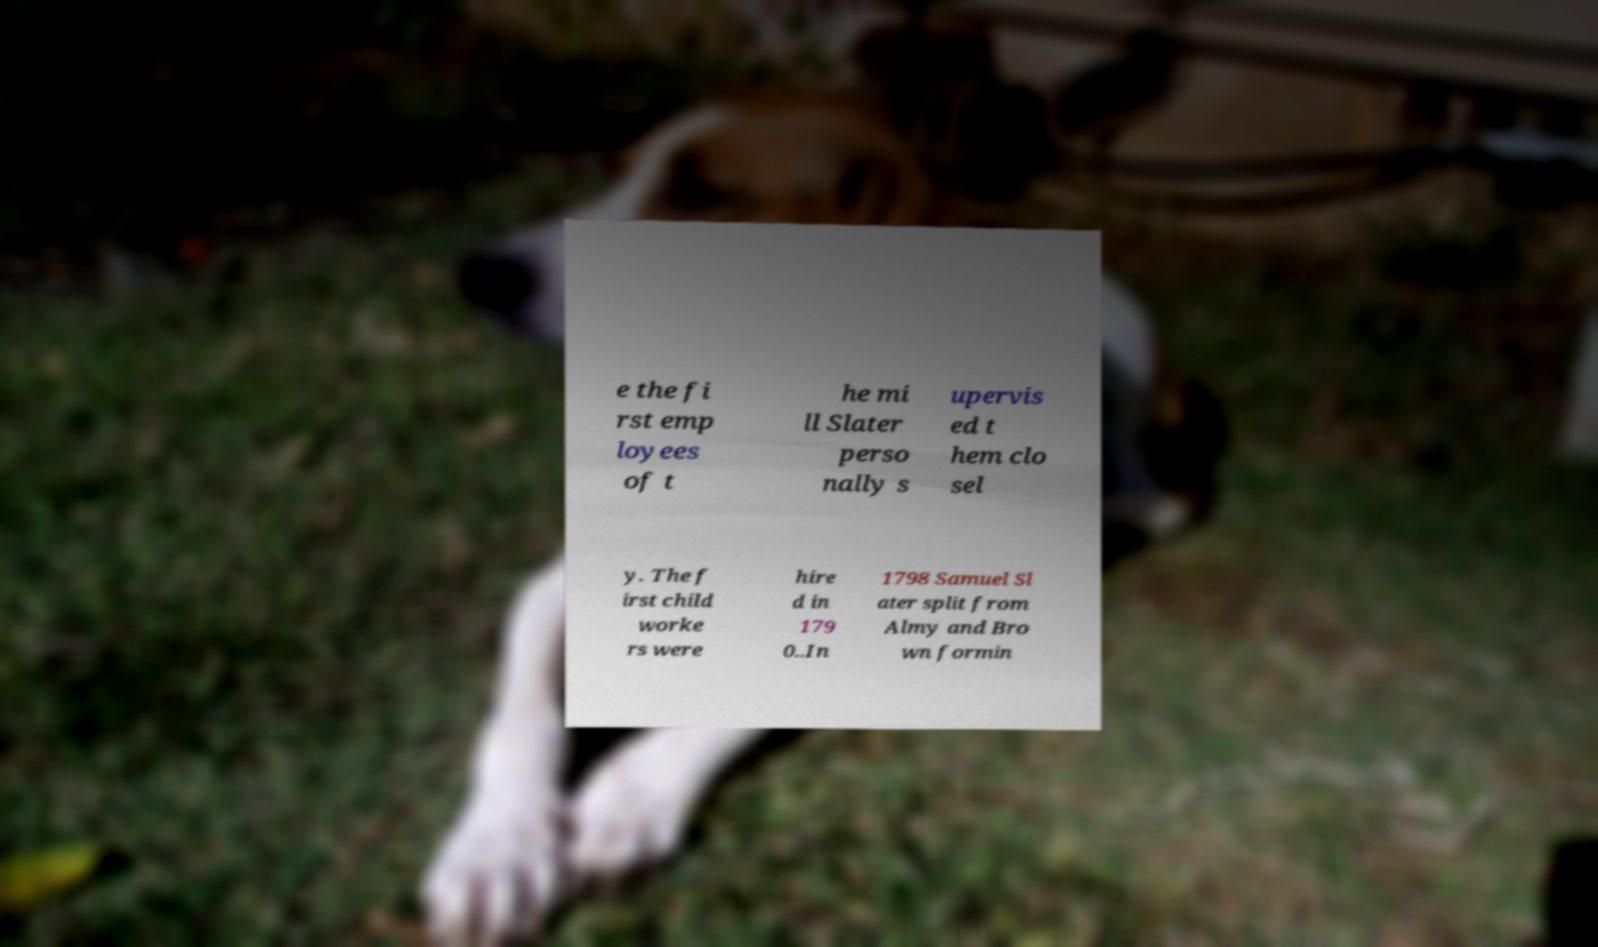I need the written content from this picture converted into text. Can you do that? e the fi rst emp loyees of t he mi ll Slater perso nally s upervis ed t hem clo sel y. The f irst child worke rs were hire d in 179 0..In 1798 Samuel Sl ater split from Almy and Bro wn formin 